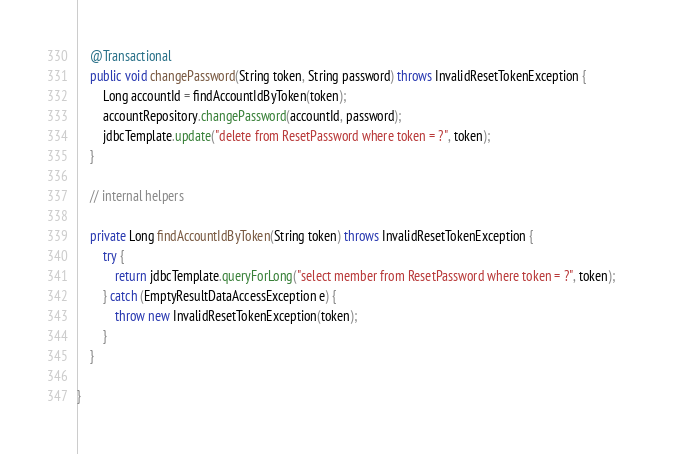Convert code to text. <code><loc_0><loc_0><loc_500><loc_500><_Java_>	@Transactional
	public void changePassword(String token, String password) throws InvalidResetTokenException {
		Long accountId = findAccountIdByToken(token);
		accountRepository.changePassword(accountId, password);
		jdbcTemplate.update("delete from ResetPassword where token = ?", token);
	}

	// internal helpers
	
	private Long findAccountIdByToken(String token) throws InvalidResetTokenException {
		try {
			return jdbcTemplate.queryForLong("select member from ResetPassword where token = ?", token);       		
		} catch (EmptyResultDataAccessException e) {
			throw new InvalidResetTokenException(token);
		}
	}

}
</code> 